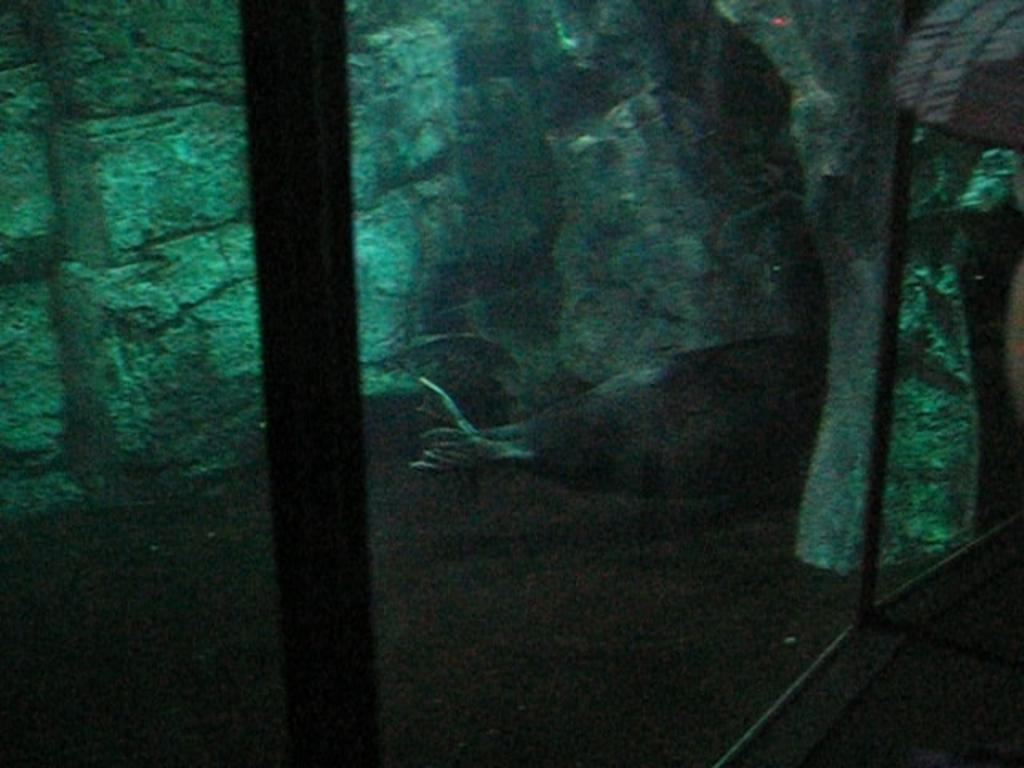What type of wall is made of glass in the image? There is a glass wall in the image. What can be seen through the glass wall? A fish in the water is visible through the glass wall. What other type of wall is present in the image? There is a stone wall in the image. What type of cord is hanging from the fish in the image? There is no cord present in the image; it features a fish in the water visible through a glass wall. Is there a road visible in the image? No, there is no road present in the image. 